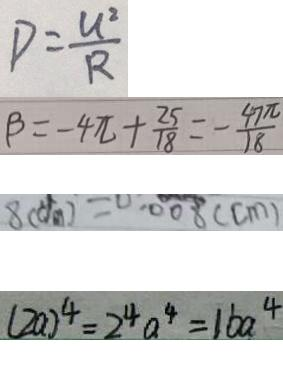<formula> <loc_0><loc_0><loc_500><loc_500>D = \frac { U ^ { 2 } } { R } 
 \beta = - 4 \pi + \frac { 2 5 } { 1 8 } = - \frac { 4 7 \pi } { 1 8 } 
 8 ( d m ) = 0 . 0 0 8 ( c m ) 
 ( 2 a ) ^ { 4 } = 2 ^ { 4 } a ^ { 4 } = 1 6 a ^ { 4 }</formula> 